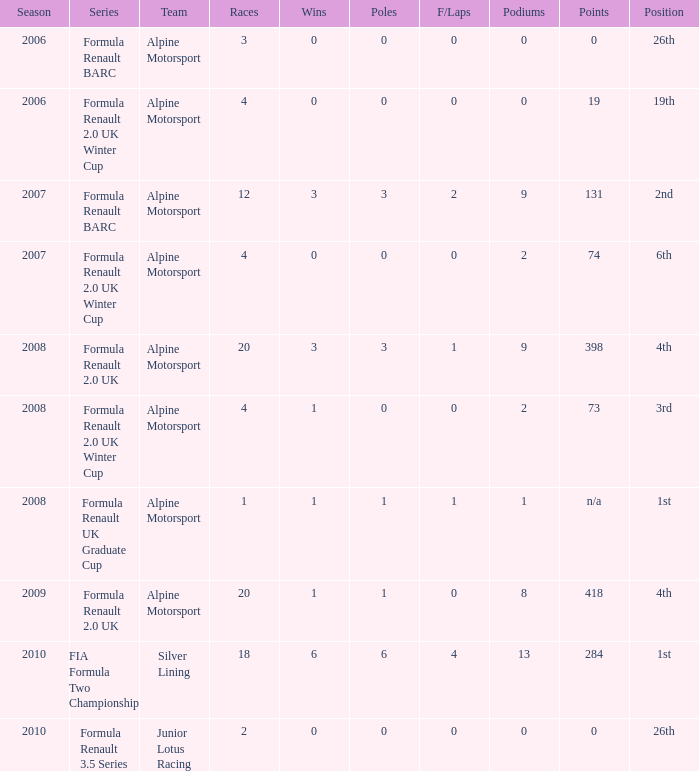What races achieved 0 f/laps and 1 pole position? 20.0. 